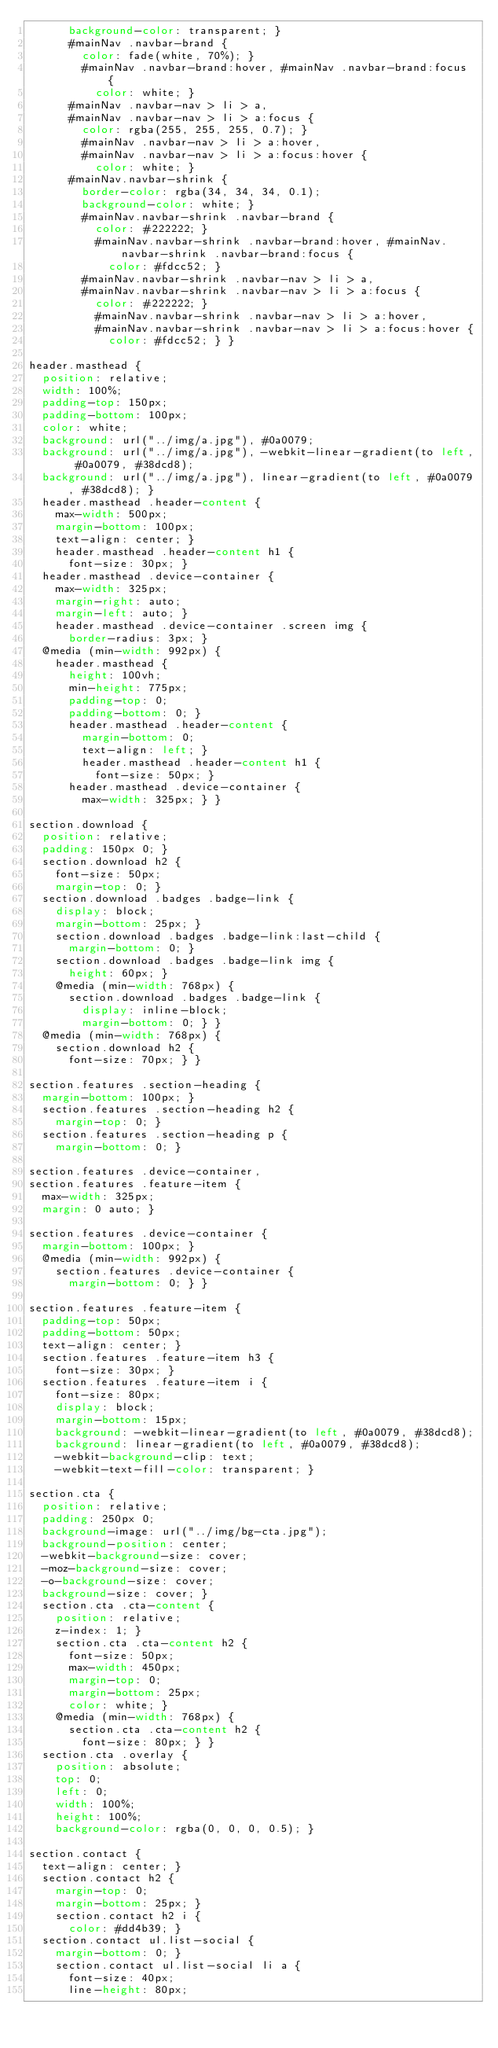Convert code to text. <code><loc_0><loc_0><loc_500><loc_500><_CSS_>      background-color: transparent; }
      #mainNav .navbar-brand {
        color: fade(white, 70%); }
        #mainNav .navbar-brand:hover, #mainNav .navbar-brand:focus {
          color: white; }
      #mainNav .navbar-nav > li > a,
      #mainNav .navbar-nav > li > a:focus {
        color: rgba(255, 255, 255, 0.7); }
        #mainNav .navbar-nav > li > a:hover,
        #mainNav .navbar-nav > li > a:focus:hover {
          color: white; }
      #mainNav.navbar-shrink {
        border-color: rgba(34, 34, 34, 0.1);
        background-color: white; }
        #mainNav.navbar-shrink .navbar-brand {
          color: #222222; }
          #mainNav.navbar-shrink .navbar-brand:hover, #mainNav.navbar-shrink .navbar-brand:focus {
            color: #fdcc52; }
        #mainNav.navbar-shrink .navbar-nav > li > a,
        #mainNav.navbar-shrink .navbar-nav > li > a:focus {
          color: #222222; }
          #mainNav.navbar-shrink .navbar-nav > li > a:hover,
          #mainNav.navbar-shrink .navbar-nav > li > a:focus:hover {
            color: #fdcc52; } }

header.masthead {
  position: relative;
  width: 100%;
  padding-top: 150px;
  padding-bottom: 100px;
  color: white;
  background: url("../img/a.jpg"), #0a0079;
  background: url("../img/a.jpg"), -webkit-linear-gradient(to left, #0a0079, #38dcd8);
  background: url("../img/a.jpg"), linear-gradient(to left, #0a0079, #38dcd8); }
  header.masthead .header-content {
    max-width: 500px;
    margin-bottom: 100px;
    text-align: center; }
    header.masthead .header-content h1 {
      font-size: 30px; }
  header.masthead .device-container {
    max-width: 325px;
    margin-right: auto;
    margin-left: auto; }
    header.masthead .device-container .screen img {
      border-radius: 3px; }
  @media (min-width: 992px) {
    header.masthead {
      height: 100vh;
      min-height: 775px;
      padding-top: 0;
      padding-bottom: 0; }
      header.masthead .header-content {
        margin-bottom: 0;
        text-align: left; }
        header.masthead .header-content h1 {
          font-size: 50px; }
      header.masthead .device-container {
        max-width: 325px; } }

section.download {
  position: relative;
  padding: 150px 0; }
  section.download h2 {
    font-size: 50px;
    margin-top: 0; }
  section.download .badges .badge-link {
    display: block;
    margin-bottom: 25px; }
    section.download .badges .badge-link:last-child {
      margin-bottom: 0; }
    section.download .badges .badge-link img {
      height: 60px; }
    @media (min-width: 768px) {
      section.download .badges .badge-link {
        display: inline-block;
        margin-bottom: 0; } }
  @media (min-width: 768px) {
    section.download h2 {
      font-size: 70px; } }

section.features .section-heading {
  margin-bottom: 100px; }
  section.features .section-heading h2 {
    margin-top: 0; }
  section.features .section-heading p {
    margin-bottom: 0; }

section.features .device-container,
section.features .feature-item {
  max-width: 325px;
  margin: 0 auto; }

section.features .device-container {
  margin-bottom: 100px; }
  @media (min-width: 992px) {
    section.features .device-container {
      margin-bottom: 0; } }

section.features .feature-item {
  padding-top: 50px;
  padding-bottom: 50px;
  text-align: center; }
  section.features .feature-item h3 {
    font-size: 30px; }
  section.features .feature-item i {
    font-size: 80px;
    display: block;
    margin-bottom: 15px;
    background: -webkit-linear-gradient(to left, #0a0079, #38dcd8);
    background: linear-gradient(to left, #0a0079, #38dcd8);
    -webkit-background-clip: text;
    -webkit-text-fill-color: transparent; }

section.cta {
  position: relative;
  padding: 250px 0;
  background-image: url("../img/bg-cta.jpg");
  background-position: center;
  -webkit-background-size: cover;
  -moz-background-size: cover;
  -o-background-size: cover;
  background-size: cover; }
  section.cta .cta-content {
    position: relative;
    z-index: 1; }
    section.cta .cta-content h2 {
      font-size: 50px;
      max-width: 450px;
      margin-top: 0;
      margin-bottom: 25px;
      color: white; }
    @media (min-width: 768px) {
      section.cta .cta-content h2 {
        font-size: 80px; } }
  section.cta .overlay {
    position: absolute;
    top: 0;
    left: 0;
    width: 100%;
    height: 100%;
    background-color: rgba(0, 0, 0, 0.5); }

section.contact {
  text-align: center; }
  section.contact h2 {
    margin-top: 0;
    margin-bottom: 25px; }
    section.contact h2 i {
      color: #dd4b39; }
  section.contact ul.list-social {
    margin-bottom: 0; }
    section.contact ul.list-social li a {
      font-size: 40px;
      line-height: 80px;</code> 